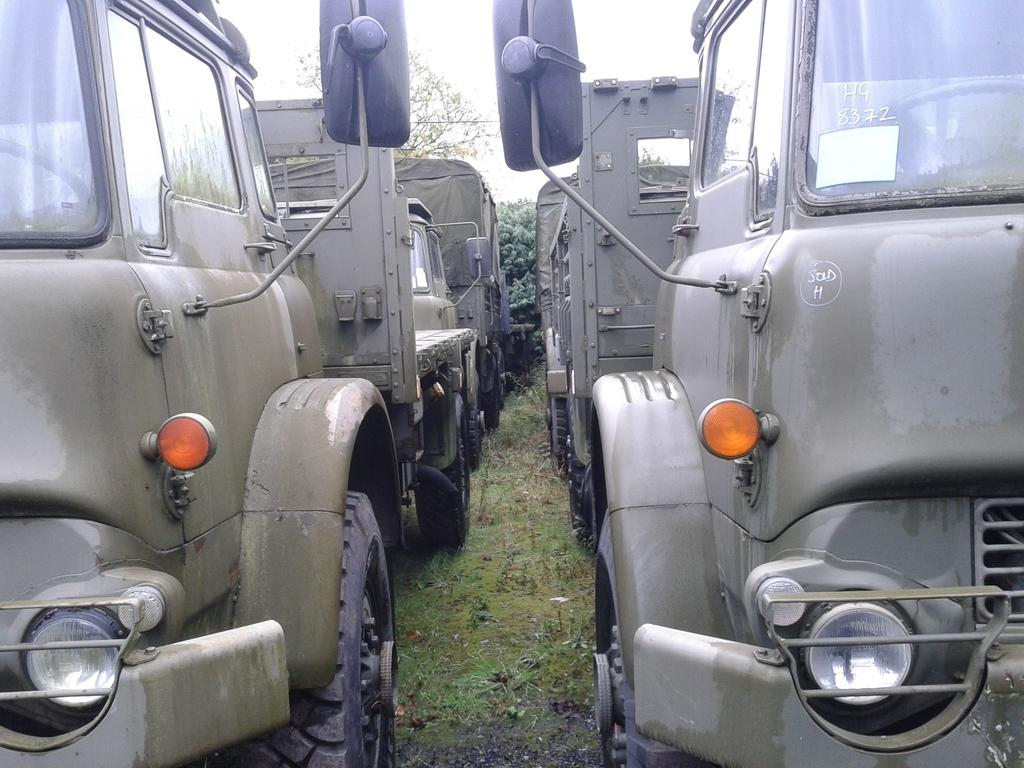What types of vehicles can be seen in the image? There are vehicles in the image, but the specific types are not mentioned. What is the natural environment visible in the image? There is grass visible in the image, and trees are in the background. What else can be seen in the image besides the vehicles and natural elements? There are other objects in the image, but their specific nature is not mentioned. What is visible in the background of the image? The sky is visible in the background of the image. Are there any bears eating corn in the image? There is no mention of bears or corn in the image; it features vehicles, grass, trees, and other objects. 